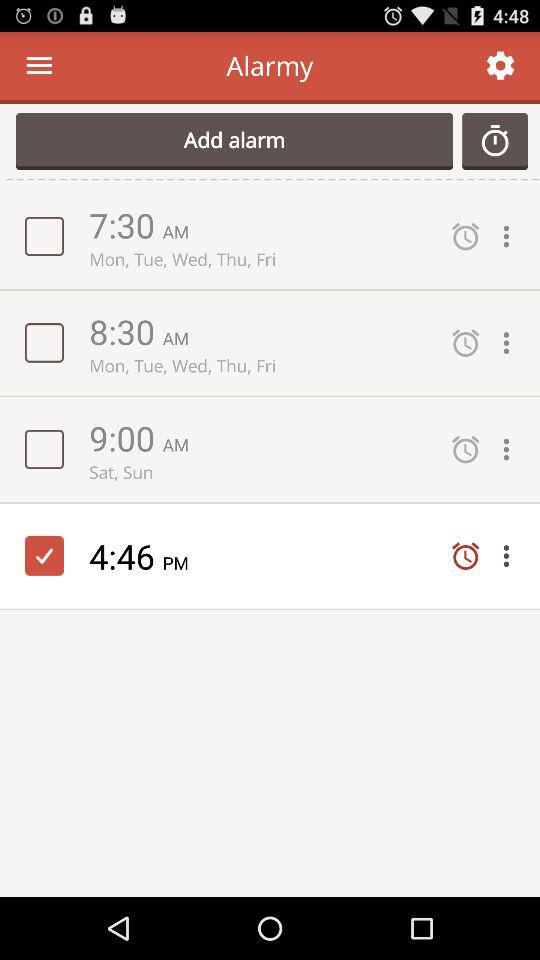What is the selected alarm checkbox? The selected alarm checkbox is at 4:46 PM. 